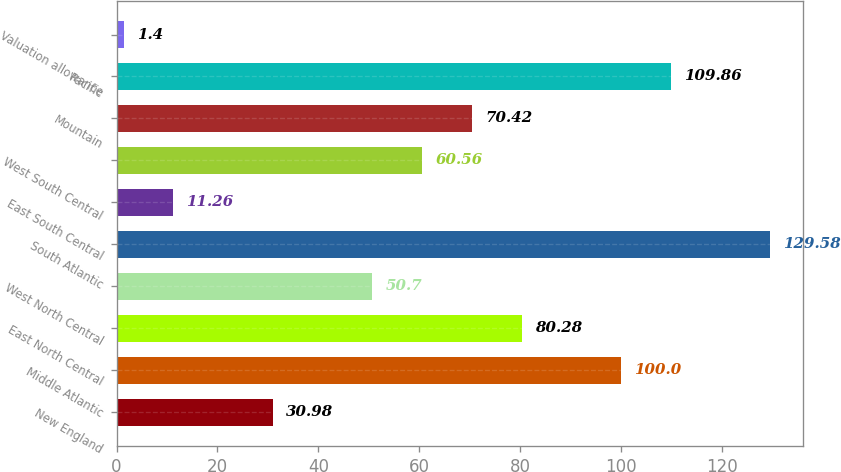Convert chart. <chart><loc_0><loc_0><loc_500><loc_500><bar_chart><fcel>New England<fcel>Middle Atlantic<fcel>East North Central<fcel>West North Central<fcel>South Atlantic<fcel>East South Central<fcel>West South Central<fcel>Mountain<fcel>Pacific<fcel>Valuation allowance<nl><fcel>30.98<fcel>100<fcel>80.28<fcel>50.7<fcel>129.58<fcel>11.26<fcel>60.56<fcel>70.42<fcel>109.86<fcel>1.4<nl></chart> 